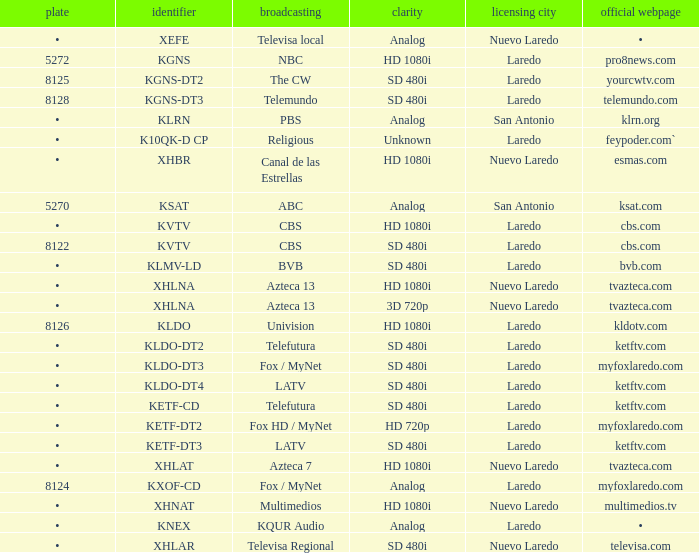Name the resolution for dish of 5270 Analog. 